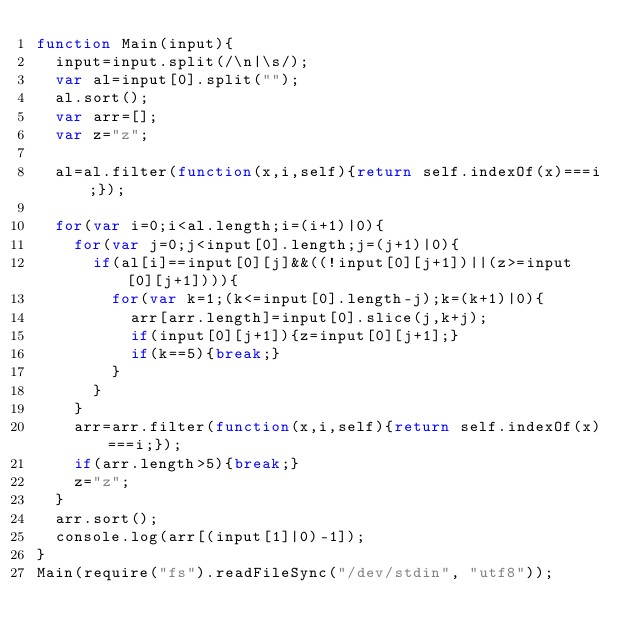Convert code to text. <code><loc_0><loc_0><loc_500><loc_500><_JavaScript_>function Main(input){
	input=input.split(/\n|\s/);
	var al=input[0].split("");
	al.sort();
	var arr=[];
	var z="z";
	
	al=al.filter(function(x,i,self){return self.indexOf(x)===i;});
	
	for(var i=0;i<al.length;i=(i+1)|0){
		for(var j=0;j<input[0].length;j=(j+1)|0){
			if(al[i]==input[0][j]&&((!input[0][j+1])||(z>=input[0][j+1]))){
				for(var k=1;(k<=input[0].length-j);k=(k+1)|0){
					arr[arr.length]=input[0].slice(j,k+j);
					if(input[0][j+1]){z=input[0][j+1];}
					if(k==5){break;}
				}
			}
		}
		arr=arr.filter(function(x,i,self){return self.indexOf(x)===i;});
		if(arr.length>5){break;}
		z="z";
	}
	arr.sort();
	console.log(arr[(input[1]|0)-1]);
}
Main(require("fs").readFileSync("/dev/stdin", "utf8"));</code> 